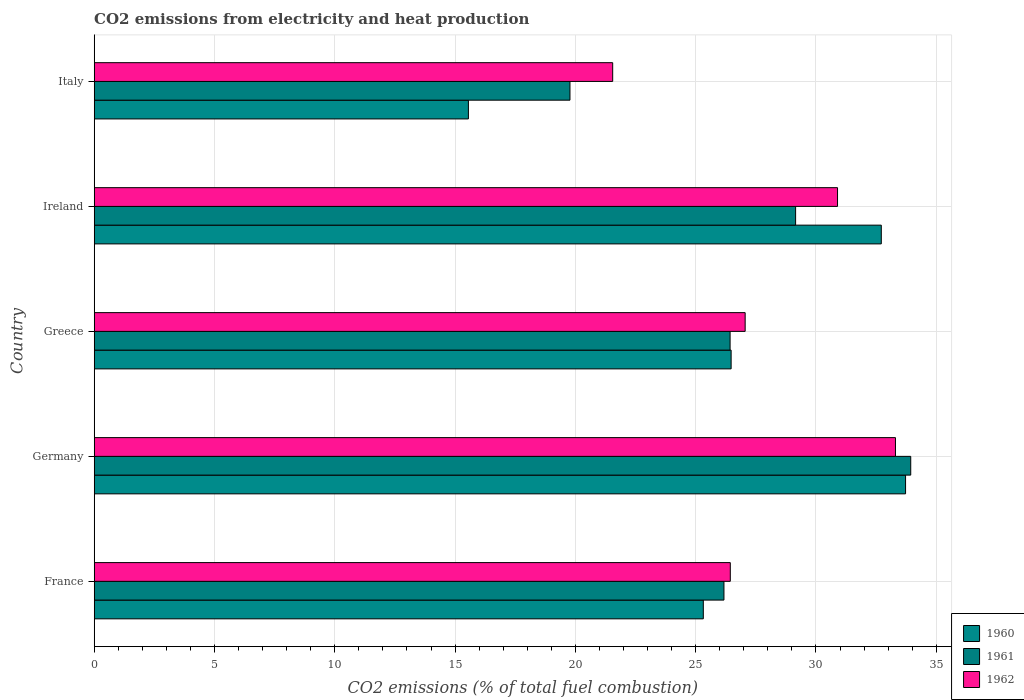How many different coloured bars are there?
Provide a succinct answer. 3. How many groups of bars are there?
Give a very brief answer. 5. Are the number of bars per tick equal to the number of legend labels?
Keep it short and to the point. Yes. Are the number of bars on each tick of the Y-axis equal?
Your response must be concise. Yes. How many bars are there on the 5th tick from the top?
Provide a succinct answer. 3. How many bars are there on the 2nd tick from the bottom?
Your answer should be compact. 3. What is the label of the 5th group of bars from the top?
Give a very brief answer. France. In how many cases, is the number of bars for a given country not equal to the number of legend labels?
Make the answer very short. 0. What is the amount of CO2 emitted in 1960 in Ireland?
Make the answer very short. 32.72. Across all countries, what is the maximum amount of CO2 emitted in 1962?
Provide a short and direct response. 33.31. Across all countries, what is the minimum amount of CO2 emitted in 1960?
Make the answer very short. 15.55. What is the total amount of CO2 emitted in 1962 in the graph?
Your answer should be compact. 139.25. What is the difference between the amount of CO2 emitted in 1961 in Germany and that in Italy?
Provide a succinct answer. 14.16. What is the difference between the amount of CO2 emitted in 1960 in Germany and the amount of CO2 emitted in 1962 in France?
Provide a short and direct response. 7.28. What is the average amount of CO2 emitted in 1962 per country?
Offer a very short reply. 27.85. What is the difference between the amount of CO2 emitted in 1961 and amount of CO2 emitted in 1960 in Greece?
Make the answer very short. -0.04. In how many countries, is the amount of CO2 emitted in 1961 greater than 6 %?
Your answer should be compact. 5. What is the ratio of the amount of CO2 emitted in 1962 in Greece to that in Italy?
Give a very brief answer. 1.26. Is the difference between the amount of CO2 emitted in 1961 in France and Ireland greater than the difference between the amount of CO2 emitted in 1960 in France and Ireland?
Your response must be concise. Yes. What is the difference between the highest and the second highest amount of CO2 emitted in 1961?
Provide a short and direct response. 4.79. What is the difference between the highest and the lowest amount of CO2 emitted in 1961?
Give a very brief answer. 14.16. In how many countries, is the amount of CO2 emitted in 1962 greater than the average amount of CO2 emitted in 1962 taken over all countries?
Give a very brief answer. 2. Is the sum of the amount of CO2 emitted in 1962 in Germany and Italy greater than the maximum amount of CO2 emitted in 1961 across all countries?
Offer a very short reply. Yes. What does the 3rd bar from the bottom in Ireland represents?
Make the answer very short. 1962. Is it the case that in every country, the sum of the amount of CO2 emitted in 1960 and amount of CO2 emitted in 1962 is greater than the amount of CO2 emitted in 1961?
Your answer should be very brief. Yes. How many bars are there?
Keep it short and to the point. 15. How many countries are there in the graph?
Ensure brevity in your answer.  5. Are the values on the major ticks of X-axis written in scientific E-notation?
Give a very brief answer. No. Does the graph contain any zero values?
Provide a succinct answer. No. What is the title of the graph?
Provide a short and direct response. CO2 emissions from electricity and heat production. What is the label or title of the X-axis?
Provide a succinct answer. CO2 emissions (% of total fuel combustion). What is the label or title of the Y-axis?
Your response must be concise. Country. What is the CO2 emissions (% of total fuel combustion) in 1960 in France?
Your response must be concise. 25.32. What is the CO2 emissions (% of total fuel combustion) in 1961 in France?
Give a very brief answer. 26.18. What is the CO2 emissions (% of total fuel combustion) in 1962 in France?
Ensure brevity in your answer.  26.44. What is the CO2 emissions (% of total fuel combustion) in 1960 in Germany?
Your answer should be compact. 33.72. What is the CO2 emissions (% of total fuel combustion) of 1961 in Germany?
Give a very brief answer. 33.94. What is the CO2 emissions (% of total fuel combustion) in 1962 in Germany?
Make the answer very short. 33.31. What is the CO2 emissions (% of total fuel combustion) in 1960 in Greece?
Make the answer very short. 26.47. What is the CO2 emissions (% of total fuel combustion) in 1961 in Greece?
Provide a succinct answer. 26.43. What is the CO2 emissions (% of total fuel combustion) of 1962 in Greece?
Ensure brevity in your answer.  27.06. What is the CO2 emissions (% of total fuel combustion) of 1960 in Ireland?
Your response must be concise. 32.72. What is the CO2 emissions (% of total fuel combustion) in 1961 in Ireland?
Your answer should be compact. 29.15. What is the CO2 emissions (% of total fuel combustion) of 1962 in Ireland?
Give a very brief answer. 30.9. What is the CO2 emissions (% of total fuel combustion) of 1960 in Italy?
Your answer should be compact. 15.55. What is the CO2 emissions (% of total fuel combustion) of 1961 in Italy?
Ensure brevity in your answer.  19.78. What is the CO2 emissions (% of total fuel combustion) of 1962 in Italy?
Ensure brevity in your answer.  21.55. Across all countries, what is the maximum CO2 emissions (% of total fuel combustion) in 1960?
Your answer should be very brief. 33.72. Across all countries, what is the maximum CO2 emissions (% of total fuel combustion) of 1961?
Offer a very short reply. 33.94. Across all countries, what is the maximum CO2 emissions (% of total fuel combustion) of 1962?
Make the answer very short. 33.31. Across all countries, what is the minimum CO2 emissions (% of total fuel combustion) of 1960?
Make the answer very short. 15.55. Across all countries, what is the minimum CO2 emissions (% of total fuel combustion) of 1961?
Your response must be concise. 19.78. Across all countries, what is the minimum CO2 emissions (% of total fuel combustion) of 1962?
Your response must be concise. 21.55. What is the total CO2 emissions (% of total fuel combustion) of 1960 in the graph?
Your response must be concise. 133.79. What is the total CO2 emissions (% of total fuel combustion) of 1961 in the graph?
Keep it short and to the point. 135.48. What is the total CO2 emissions (% of total fuel combustion) in 1962 in the graph?
Ensure brevity in your answer.  139.25. What is the difference between the CO2 emissions (% of total fuel combustion) of 1960 in France and that in Germany?
Ensure brevity in your answer.  -8.41. What is the difference between the CO2 emissions (% of total fuel combustion) in 1961 in France and that in Germany?
Give a very brief answer. -7.76. What is the difference between the CO2 emissions (% of total fuel combustion) of 1962 in France and that in Germany?
Give a very brief answer. -6.87. What is the difference between the CO2 emissions (% of total fuel combustion) in 1960 in France and that in Greece?
Offer a very short reply. -1.16. What is the difference between the CO2 emissions (% of total fuel combustion) of 1961 in France and that in Greece?
Your answer should be very brief. -0.26. What is the difference between the CO2 emissions (% of total fuel combustion) of 1962 in France and that in Greece?
Give a very brief answer. -0.62. What is the difference between the CO2 emissions (% of total fuel combustion) of 1960 in France and that in Ireland?
Make the answer very short. -7.4. What is the difference between the CO2 emissions (% of total fuel combustion) of 1961 in France and that in Ireland?
Keep it short and to the point. -2.98. What is the difference between the CO2 emissions (% of total fuel combustion) in 1962 in France and that in Ireland?
Keep it short and to the point. -4.46. What is the difference between the CO2 emissions (% of total fuel combustion) in 1960 in France and that in Italy?
Ensure brevity in your answer.  9.76. What is the difference between the CO2 emissions (% of total fuel combustion) in 1961 in France and that in Italy?
Provide a succinct answer. 6.4. What is the difference between the CO2 emissions (% of total fuel combustion) of 1962 in France and that in Italy?
Offer a very short reply. 4.89. What is the difference between the CO2 emissions (% of total fuel combustion) in 1960 in Germany and that in Greece?
Offer a very short reply. 7.25. What is the difference between the CO2 emissions (% of total fuel combustion) of 1961 in Germany and that in Greece?
Ensure brevity in your answer.  7.51. What is the difference between the CO2 emissions (% of total fuel combustion) of 1962 in Germany and that in Greece?
Make the answer very short. 6.25. What is the difference between the CO2 emissions (% of total fuel combustion) of 1960 in Germany and that in Ireland?
Provide a succinct answer. 1.01. What is the difference between the CO2 emissions (% of total fuel combustion) of 1961 in Germany and that in Ireland?
Give a very brief answer. 4.79. What is the difference between the CO2 emissions (% of total fuel combustion) of 1962 in Germany and that in Ireland?
Give a very brief answer. 2.41. What is the difference between the CO2 emissions (% of total fuel combustion) of 1960 in Germany and that in Italy?
Make the answer very short. 18.17. What is the difference between the CO2 emissions (% of total fuel combustion) of 1961 in Germany and that in Italy?
Your answer should be very brief. 14.16. What is the difference between the CO2 emissions (% of total fuel combustion) of 1962 in Germany and that in Italy?
Give a very brief answer. 11.75. What is the difference between the CO2 emissions (% of total fuel combustion) in 1960 in Greece and that in Ireland?
Make the answer very short. -6.24. What is the difference between the CO2 emissions (% of total fuel combustion) of 1961 in Greece and that in Ireland?
Ensure brevity in your answer.  -2.72. What is the difference between the CO2 emissions (% of total fuel combustion) in 1962 in Greece and that in Ireland?
Offer a terse response. -3.84. What is the difference between the CO2 emissions (% of total fuel combustion) of 1960 in Greece and that in Italy?
Provide a succinct answer. 10.92. What is the difference between the CO2 emissions (% of total fuel combustion) in 1961 in Greece and that in Italy?
Offer a very short reply. 6.66. What is the difference between the CO2 emissions (% of total fuel combustion) of 1962 in Greece and that in Italy?
Make the answer very short. 5.51. What is the difference between the CO2 emissions (% of total fuel combustion) of 1960 in Ireland and that in Italy?
Provide a short and direct response. 17.16. What is the difference between the CO2 emissions (% of total fuel combustion) of 1961 in Ireland and that in Italy?
Keep it short and to the point. 9.38. What is the difference between the CO2 emissions (% of total fuel combustion) of 1962 in Ireland and that in Italy?
Keep it short and to the point. 9.35. What is the difference between the CO2 emissions (% of total fuel combustion) in 1960 in France and the CO2 emissions (% of total fuel combustion) in 1961 in Germany?
Provide a short and direct response. -8.62. What is the difference between the CO2 emissions (% of total fuel combustion) of 1960 in France and the CO2 emissions (% of total fuel combustion) of 1962 in Germany?
Your answer should be very brief. -7.99. What is the difference between the CO2 emissions (% of total fuel combustion) of 1961 in France and the CO2 emissions (% of total fuel combustion) of 1962 in Germany?
Your response must be concise. -7.13. What is the difference between the CO2 emissions (% of total fuel combustion) of 1960 in France and the CO2 emissions (% of total fuel combustion) of 1961 in Greece?
Your answer should be compact. -1.11. What is the difference between the CO2 emissions (% of total fuel combustion) of 1960 in France and the CO2 emissions (% of total fuel combustion) of 1962 in Greece?
Your answer should be very brief. -1.74. What is the difference between the CO2 emissions (% of total fuel combustion) in 1961 in France and the CO2 emissions (% of total fuel combustion) in 1962 in Greece?
Keep it short and to the point. -0.88. What is the difference between the CO2 emissions (% of total fuel combustion) in 1960 in France and the CO2 emissions (% of total fuel combustion) in 1961 in Ireland?
Your response must be concise. -3.84. What is the difference between the CO2 emissions (% of total fuel combustion) in 1960 in France and the CO2 emissions (% of total fuel combustion) in 1962 in Ireland?
Offer a terse response. -5.58. What is the difference between the CO2 emissions (% of total fuel combustion) in 1961 in France and the CO2 emissions (% of total fuel combustion) in 1962 in Ireland?
Your answer should be very brief. -4.72. What is the difference between the CO2 emissions (% of total fuel combustion) of 1960 in France and the CO2 emissions (% of total fuel combustion) of 1961 in Italy?
Provide a succinct answer. 5.54. What is the difference between the CO2 emissions (% of total fuel combustion) in 1960 in France and the CO2 emissions (% of total fuel combustion) in 1962 in Italy?
Keep it short and to the point. 3.77. What is the difference between the CO2 emissions (% of total fuel combustion) of 1961 in France and the CO2 emissions (% of total fuel combustion) of 1962 in Italy?
Your answer should be compact. 4.62. What is the difference between the CO2 emissions (% of total fuel combustion) in 1960 in Germany and the CO2 emissions (% of total fuel combustion) in 1961 in Greece?
Offer a terse response. 7.29. What is the difference between the CO2 emissions (% of total fuel combustion) of 1960 in Germany and the CO2 emissions (% of total fuel combustion) of 1962 in Greece?
Provide a succinct answer. 6.67. What is the difference between the CO2 emissions (% of total fuel combustion) of 1961 in Germany and the CO2 emissions (% of total fuel combustion) of 1962 in Greece?
Your answer should be compact. 6.88. What is the difference between the CO2 emissions (% of total fuel combustion) of 1960 in Germany and the CO2 emissions (% of total fuel combustion) of 1961 in Ireland?
Keep it short and to the point. 4.57. What is the difference between the CO2 emissions (% of total fuel combustion) in 1960 in Germany and the CO2 emissions (% of total fuel combustion) in 1962 in Ireland?
Your answer should be compact. 2.83. What is the difference between the CO2 emissions (% of total fuel combustion) in 1961 in Germany and the CO2 emissions (% of total fuel combustion) in 1962 in Ireland?
Offer a very short reply. 3.04. What is the difference between the CO2 emissions (% of total fuel combustion) in 1960 in Germany and the CO2 emissions (% of total fuel combustion) in 1961 in Italy?
Provide a succinct answer. 13.95. What is the difference between the CO2 emissions (% of total fuel combustion) in 1960 in Germany and the CO2 emissions (% of total fuel combustion) in 1962 in Italy?
Keep it short and to the point. 12.17. What is the difference between the CO2 emissions (% of total fuel combustion) in 1961 in Germany and the CO2 emissions (% of total fuel combustion) in 1962 in Italy?
Offer a terse response. 12.39. What is the difference between the CO2 emissions (% of total fuel combustion) of 1960 in Greece and the CO2 emissions (% of total fuel combustion) of 1961 in Ireland?
Give a very brief answer. -2.68. What is the difference between the CO2 emissions (% of total fuel combustion) in 1960 in Greece and the CO2 emissions (% of total fuel combustion) in 1962 in Ireland?
Your answer should be compact. -4.42. What is the difference between the CO2 emissions (% of total fuel combustion) of 1961 in Greece and the CO2 emissions (% of total fuel combustion) of 1962 in Ireland?
Your answer should be compact. -4.47. What is the difference between the CO2 emissions (% of total fuel combustion) of 1960 in Greece and the CO2 emissions (% of total fuel combustion) of 1961 in Italy?
Keep it short and to the point. 6.7. What is the difference between the CO2 emissions (% of total fuel combustion) in 1960 in Greece and the CO2 emissions (% of total fuel combustion) in 1962 in Italy?
Provide a succinct answer. 4.92. What is the difference between the CO2 emissions (% of total fuel combustion) of 1961 in Greece and the CO2 emissions (% of total fuel combustion) of 1962 in Italy?
Give a very brief answer. 4.88. What is the difference between the CO2 emissions (% of total fuel combustion) in 1960 in Ireland and the CO2 emissions (% of total fuel combustion) in 1961 in Italy?
Your answer should be compact. 12.94. What is the difference between the CO2 emissions (% of total fuel combustion) of 1960 in Ireland and the CO2 emissions (% of total fuel combustion) of 1962 in Italy?
Provide a succinct answer. 11.16. What is the difference between the CO2 emissions (% of total fuel combustion) of 1961 in Ireland and the CO2 emissions (% of total fuel combustion) of 1962 in Italy?
Offer a terse response. 7.6. What is the average CO2 emissions (% of total fuel combustion) in 1960 per country?
Offer a very short reply. 26.76. What is the average CO2 emissions (% of total fuel combustion) in 1961 per country?
Offer a terse response. 27.1. What is the average CO2 emissions (% of total fuel combustion) in 1962 per country?
Your response must be concise. 27.85. What is the difference between the CO2 emissions (% of total fuel combustion) of 1960 and CO2 emissions (% of total fuel combustion) of 1961 in France?
Ensure brevity in your answer.  -0.86. What is the difference between the CO2 emissions (% of total fuel combustion) in 1960 and CO2 emissions (% of total fuel combustion) in 1962 in France?
Provide a short and direct response. -1.12. What is the difference between the CO2 emissions (% of total fuel combustion) in 1961 and CO2 emissions (% of total fuel combustion) in 1962 in France?
Your response must be concise. -0.26. What is the difference between the CO2 emissions (% of total fuel combustion) in 1960 and CO2 emissions (% of total fuel combustion) in 1961 in Germany?
Your response must be concise. -0.21. What is the difference between the CO2 emissions (% of total fuel combustion) in 1960 and CO2 emissions (% of total fuel combustion) in 1962 in Germany?
Make the answer very short. 0.42. What is the difference between the CO2 emissions (% of total fuel combustion) in 1961 and CO2 emissions (% of total fuel combustion) in 1962 in Germany?
Provide a succinct answer. 0.63. What is the difference between the CO2 emissions (% of total fuel combustion) of 1960 and CO2 emissions (% of total fuel combustion) of 1961 in Greece?
Your response must be concise. 0.04. What is the difference between the CO2 emissions (% of total fuel combustion) in 1960 and CO2 emissions (% of total fuel combustion) in 1962 in Greece?
Offer a very short reply. -0.58. What is the difference between the CO2 emissions (% of total fuel combustion) in 1961 and CO2 emissions (% of total fuel combustion) in 1962 in Greece?
Your answer should be compact. -0.63. What is the difference between the CO2 emissions (% of total fuel combustion) in 1960 and CO2 emissions (% of total fuel combustion) in 1961 in Ireland?
Ensure brevity in your answer.  3.56. What is the difference between the CO2 emissions (% of total fuel combustion) of 1960 and CO2 emissions (% of total fuel combustion) of 1962 in Ireland?
Provide a short and direct response. 1.82. What is the difference between the CO2 emissions (% of total fuel combustion) of 1961 and CO2 emissions (% of total fuel combustion) of 1962 in Ireland?
Keep it short and to the point. -1.74. What is the difference between the CO2 emissions (% of total fuel combustion) of 1960 and CO2 emissions (% of total fuel combustion) of 1961 in Italy?
Your response must be concise. -4.22. What is the difference between the CO2 emissions (% of total fuel combustion) in 1960 and CO2 emissions (% of total fuel combustion) in 1962 in Italy?
Keep it short and to the point. -6. What is the difference between the CO2 emissions (% of total fuel combustion) of 1961 and CO2 emissions (% of total fuel combustion) of 1962 in Italy?
Keep it short and to the point. -1.78. What is the ratio of the CO2 emissions (% of total fuel combustion) in 1960 in France to that in Germany?
Your response must be concise. 0.75. What is the ratio of the CO2 emissions (% of total fuel combustion) in 1961 in France to that in Germany?
Give a very brief answer. 0.77. What is the ratio of the CO2 emissions (% of total fuel combustion) in 1962 in France to that in Germany?
Ensure brevity in your answer.  0.79. What is the ratio of the CO2 emissions (% of total fuel combustion) in 1960 in France to that in Greece?
Provide a short and direct response. 0.96. What is the ratio of the CO2 emissions (% of total fuel combustion) of 1961 in France to that in Greece?
Keep it short and to the point. 0.99. What is the ratio of the CO2 emissions (% of total fuel combustion) of 1962 in France to that in Greece?
Provide a short and direct response. 0.98. What is the ratio of the CO2 emissions (% of total fuel combustion) in 1960 in France to that in Ireland?
Your response must be concise. 0.77. What is the ratio of the CO2 emissions (% of total fuel combustion) of 1961 in France to that in Ireland?
Provide a short and direct response. 0.9. What is the ratio of the CO2 emissions (% of total fuel combustion) in 1962 in France to that in Ireland?
Give a very brief answer. 0.86. What is the ratio of the CO2 emissions (% of total fuel combustion) in 1960 in France to that in Italy?
Give a very brief answer. 1.63. What is the ratio of the CO2 emissions (% of total fuel combustion) of 1961 in France to that in Italy?
Offer a very short reply. 1.32. What is the ratio of the CO2 emissions (% of total fuel combustion) of 1962 in France to that in Italy?
Make the answer very short. 1.23. What is the ratio of the CO2 emissions (% of total fuel combustion) of 1960 in Germany to that in Greece?
Provide a short and direct response. 1.27. What is the ratio of the CO2 emissions (% of total fuel combustion) of 1961 in Germany to that in Greece?
Offer a very short reply. 1.28. What is the ratio of the CO2 emissions (% of total fuel combustion) in 1962 in Germany to that in Greece?
Keep it short and to the point. 1.23. What is the ratio of the CO2 emissions (% of total fuel combustion) in 1960 in Germany to that in Ireland?
Ensure brevity in your answer.  1.03. What is the ratio of the CO2 emissions (% of total fuel combustion) in 1961 in Germany to that in Ireland?
Your answer should be compact. 1.16. What is the ratio of the CO2 emissions (% of total fuel combustion) in 1962 in Germany to that in Ireland?
Your answer should be very brief. 1.08. What is the ratio of the CO2 emissions (% of total fuel combustion) of 1960 in Germany to that in Italy?
Your answer should be very brief. 2.17. What is the ratio of the CO2 emissions (% of total fuel combustion) of 1961 in Germany to that in Italy?
Keep it short and to the point. 1.72. What is the ratio of the CO2 emissions (% of total fuel combustion) in 1962 in Germany to that in Italy?
Provide a short and direct response. 1.55. What is the ratio of the CO2 emissions (% of total fuel combustion) of 1960 in Greece to that in Ireland?
Your answer should be compact. 0.81. What is the ratio of the CO2 emissions (% of total fuel combustion) in 1961 in Greece to that in Ireland?
Ensure brevity in your answer.  0.91. What is the ratio of the CO2 emissions (% of total fuel combustion) in 1962 in Greece to that in Ireland?
Ensure brevity in your answer.  0.88. What is the ratio of the CO2 emissions (% of total fuel combustion) of 1960 in Greece to that in Italy?
Keep it short and to the point. 1.7. What is the ratio of the CO2 emissions (% of total fuel combustion) of 1961 in Greece to that in Italy?
Provide a short and direct response. 1.34. What is the ratio of the CO2 emissions (% of total fuel combustion) of 1962 in Greece to that in Italy?
Ensure brevity in your answer.  1.26. What is the ratio of the CO2 emissions (% of total fuel combustion) in 1960 in Ireland to that in Italy?
Your answer should be very brief. 2.1. What is the ratio of the CO2 emissions (% of total fuel combustion) of 1961 in Ireland to that in Italy?
Make the answer very short. 1.47. What is the ratio of the CO2 emissions (% of total fuel combustion) of 1962 in Ireland to that in Italy?
Ensure brevity in your answer.  1.43. What is the difference between the highest and the second highest CO2 emissions (% of total fuel combustion) of 1960?
Provide a succinct answer. 1.01. What is the difference between the highest and the second highest CO2 emissions (% of total fuel combustion) in 1961?
Ensure brevity in your answer.  4.79. What is the difference between the highest and the second highest CO2 emissions (% of total fuel combustion) of 1962?
Your answer should be compact. 2.41. What is the difference between the highest and the lowest CO2 emissions (% of total fuel combustion) in 1960?
Offer a very short reply. 18.17. What is the difference between the highest and the lowest CO2 emissions (% of total fuel combustion) of 1961?
Make the answer very short. 14.16. What is the difference between the highest and the lowest CO2 emissions (% of total fuel combustion) of 1962?
Your response must be concise. 11.75. 